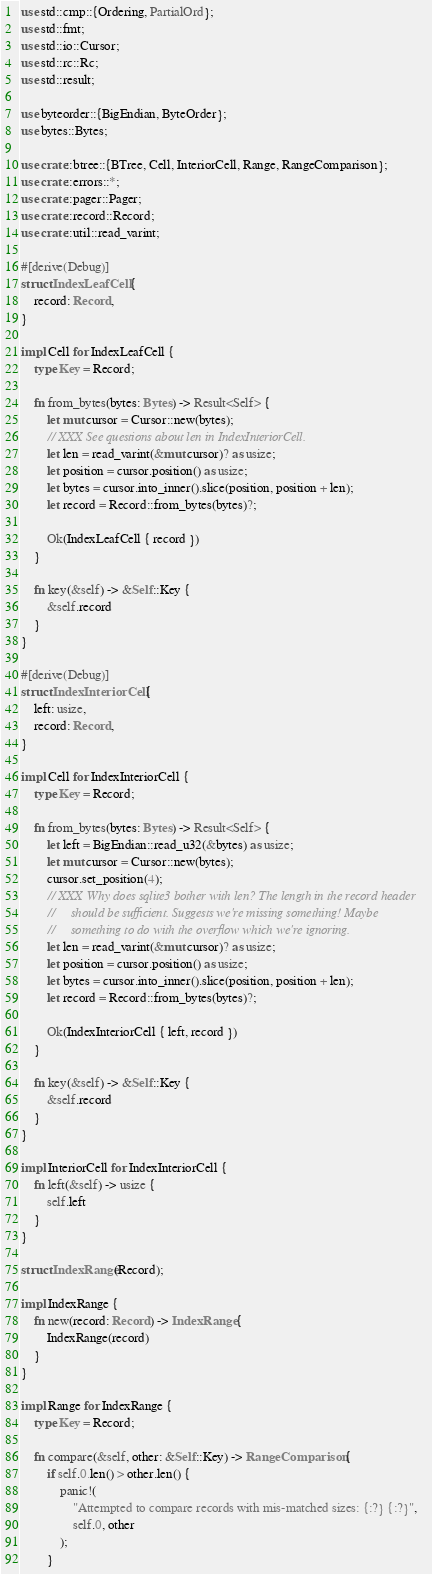<code> <loc_0><loc_0><loc_500><loc_500><_Rust_>use std::cmp::{Ordering, PartialOrd};
use std::fmt;
use std::io::Cursor;
use std::rc::Rc;
use std::result;

use byteorder::{BigEndian, ByteOrder};
use bytes::Bytes;

use crate::btree::{BTree, Cell, InteriorCell, Range, RangeComparison};
use crate::errors::*;
use crate::pager::Pager;
use crate::record::Record;
use crate::util::read_varint;

#[derive(Debug)]
struct IndexLeafCell {
    record: Record,
}

impl Cell for IndexLeafCell {
    type Key = Record;

    fn from_bytes(bytes: Bytes) -> Result<Self> {
        let mut cursor = Cursor::new(bytes);
        // XXX See questions about len in IndexInteriorCell.
        let len = read_varint(&mut cursor)? as usize;
        let position = cursor.position() as usize;
        let bytes = cursor.into_inner().slice(position, position + len);
        let record = Record::from_bytes(bytes)?;

        Ok(IndexLeafCell { record })
    }

    fn key(&self) -> &Self::Key {
        &self.record
    }
}

#[derive(Debug)]
struct IndexInteriorCell {
    left: usize,
    record: Record,
}

impl Cell for IndexInteriorCell {
    type Key = Record;

    fn from_bytes(bytes: Bytes) -> Result<Self> {
        let left = BigEndian::read_u32(&bytes) as usize;
        let mut cursor = Cursor::new(bytes);
        cursor.set_position(4);
        // XXX Why does sqlite3 bother with len? The length in the record header
        //     should be sufficient. Suggests we're missing something! Maybe
        //     something to do with the overflow which we're ignoring.
        let len = read_varint(&mut cursor)? as usize;
        let position = cursor.position() as usize;
        let bytes = cursor.into_inner().slice(position, position + len);
        let record = Record::from_bytes(bytes)?;

        Ok(IndexInteriorCell { left, record })
    }

    fn key(&self) -> &Self::Key {
        &self.record
    }
}

impl InteriorCell for IndexInteriorCell {
    fn left(&self) -> usize {
        self.left
    }
}

struct IndexRange(Record);

impl IndexRange {
    fn new(record: Record) -> IndexRange {
        IndexRange(record)
    }
}

impl Range for IndexRange {
    type Key = Record;

    fn compare(&self, other: &Self::Key) -> RangeComparison {
        if self.0.len() > other.len() {
            panic!(
                "Attempted to compare records with mis-matched sizes: {:?} {:?}",
                self.0, other
            );
        }</code> 